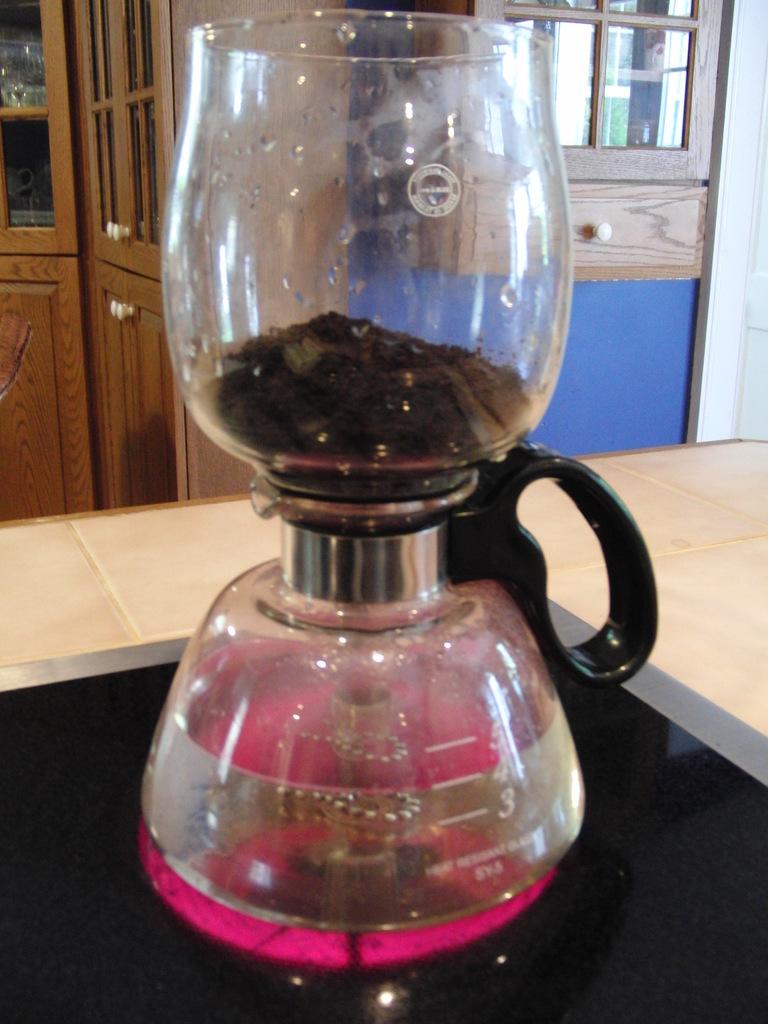Is the waterlevel at -4?
Offer a terse response. Yes. How far is the water from level -3?
Provide a short and direct response. 1. 